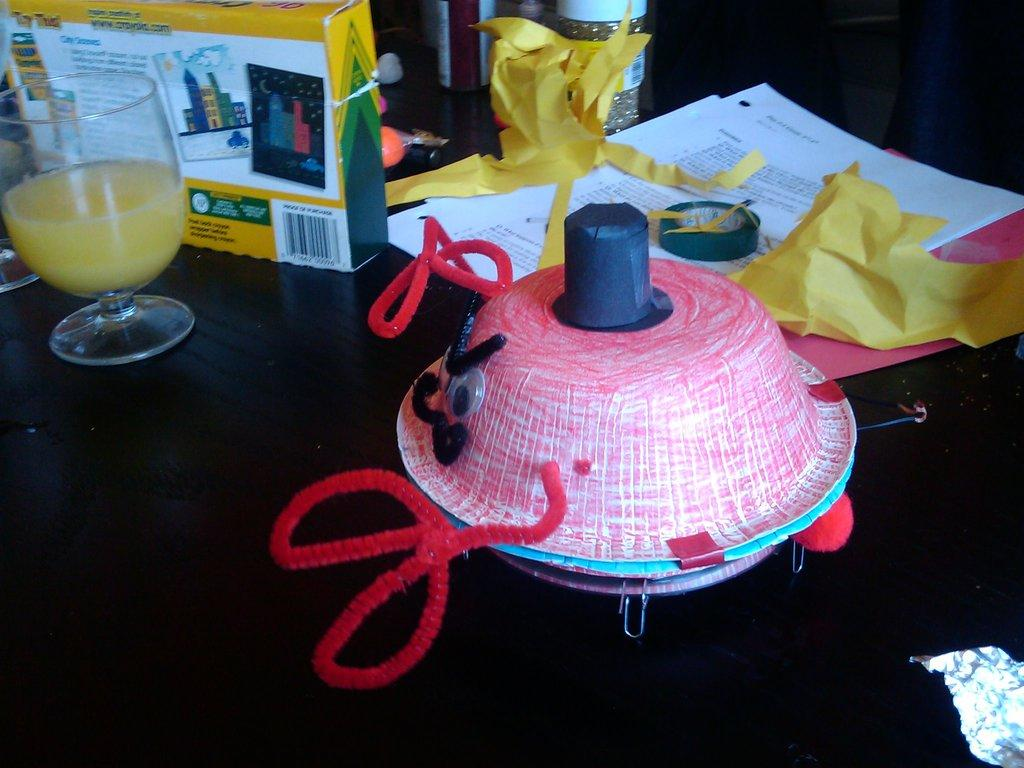What object is placed on the table in the image? There is a hat placed on the table. What else can be seen on the table? There is a glass, papers, a tape, and a box on the table. What might be used for holding a beverage in the image? The glass on the table might be used for holding a beverage. What could be used for attaching or securing items in the image? The tape on the table could be used for attaching or securing items. How many brothers are present in the image? There are no brothers present in the image; it only features objects on a table. What type of animal can be seen interacting with the hat in the image? There is no animal present in the image; it only features objects on a table. 